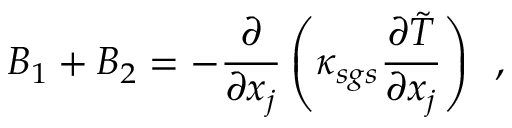<formula> <loc_0><loc_0><loc_500><loc_500>B _ { 1 } + B _ { 2 } = - \frac { \partial } { \partial x _ { j } } \left ( \kappa _ { s g s } \frac { \partial \tilde { T } } { \partial x _ { j } } \right ) \, ,</formula> 